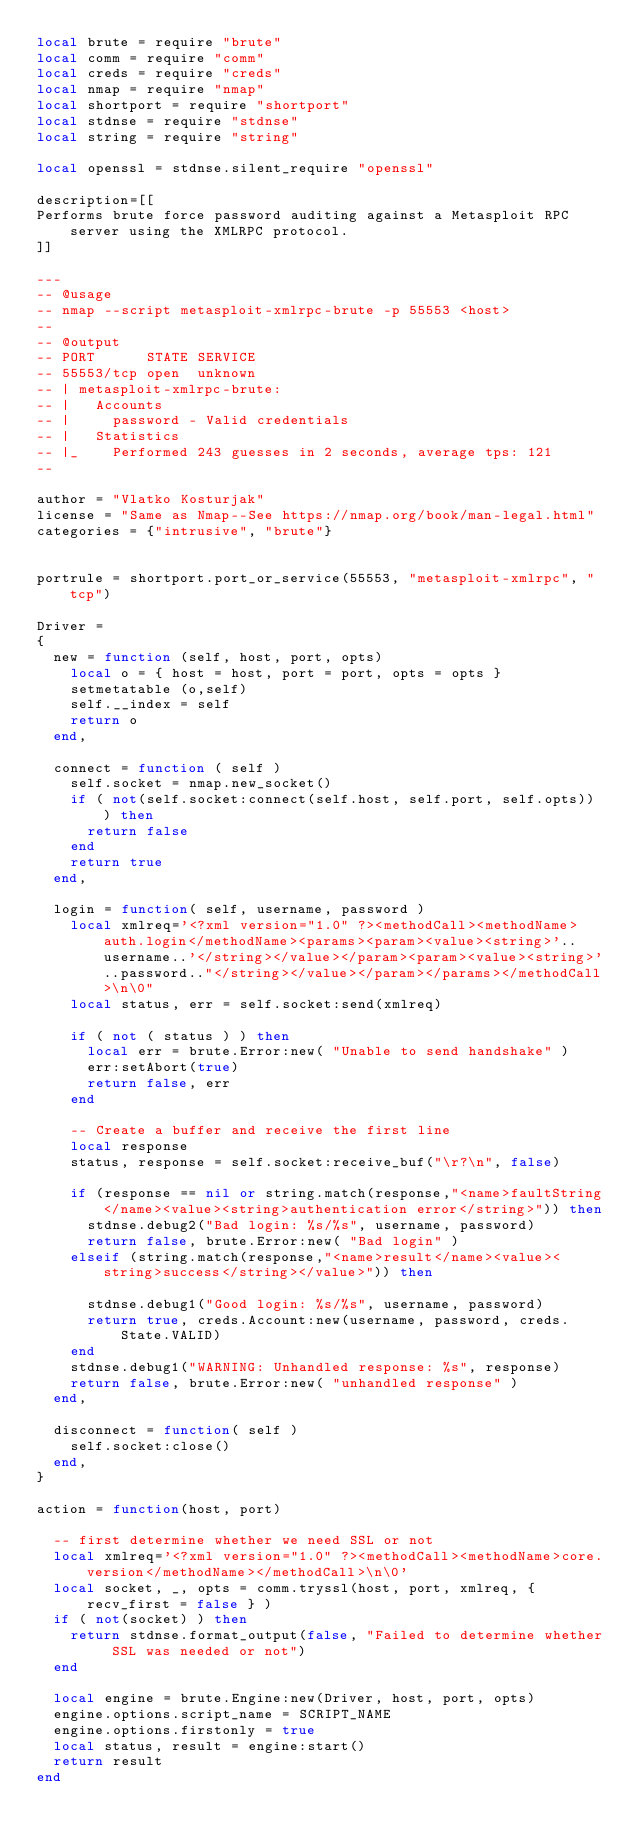Convert code to text. <code><loc_0><loc_0><loc_500><loc_500><_Lua_>local brute = require "brute"
local comm = require "comm"
local creds = require "creds"
local nmap = require "nmap"
local shortport = require "shortport"
local stdnse = require "stdnse"
local string = require "string"

local openssl = stdnse.silent_require "openssl"

description=[[
Performs brute force password auditing against a Metasploit RPC server using the XMLRPC protocol.
]]

---
-- @usage
-- nmap --script metasploit-xmlrpc-brute -p 55553 <host>
--
-- @output
-- PORT      STATE SERVICE
-- 55553/tcp open  unknown
-- | metasploit-xmlrpc-brute:
-- |   Accounts
-- |     password - Valid credentials
-- |   Statistics
-- |_    Performed 243 guesses in 2 seconds, average tps: 121
--

author = "Vlatko Kosturjak"
license = "Same as Nmap--See https://nmap.org/book/man-legal.html"
categories = {"intrusive", "brute"}


portrule = shortport.port_or_service(55553, "metasploit-xmlrpc", "tcp")

Driver =
{
  new = function (self, host, port, opts)
    local o = { host = host, port = port, opts = opts }
    setmetatable (o,self)
    self.__index = self
    return o
  end,

  connect = function ( self )
    self.socket = nmap.new_socket()
    if ( not(self.socket:connect(self.host, self.port, self.opts)) ) then
      return false
    end
    return true
  end,

  login = function( self, username, password )
    local xmlreq='<?xml version="1.0" ?><methodCall><methodName>auth.login</methodName><params><param><value><string>'..username..'</string></value></param><param><value><string>'..password.."</string></value></param></params></methodCall>\n\0"
    local status, err = self.socket:send(xmlreq)

    if ( not ( status ) ) then
      local err = brute.Error:new( "Unable to send handshake" )
      err:setAbort(true)
      return false, err
    end

    -- Create a buffer and receive the first line
    local response
    status, response = self.socket:receive_buf("\r?\n", false)

    if (response == nil or string.match(response,"<name>faultString</name><value><string>authentication error</string>")) then
      stdnse.debug2("Bad login: %s/%s", username, password)
      return false, brute.Error:new( "Bad login" )
    elseif (string.match(response,"<name>result</name><value><string>success</string></value>")) then

      stdnse.debug1("Good login: %s/%s", username, password)
      return true, creds.Account:new(username, password, creds.State.VALID)
    end
    stdnse.debug1("WARNING: Unhandled response: %s", response)
    return false, brute.Error:new( "unhandled response" )
  end,

  disconnect = function( self )
    self.socket:close()
  end,
}

action = function(host, port)

  -- first determine whether we need SSL or not
  local xmlreq='<?xml version="1.0" ?><methodCall><methodName>core.version</methodName></methodCall>\n\0'
  local socket, _, opts = comm.tryssl(host, port, xmlreq, { recv_first = false } )
  if ( not(socket) ) then
    return stdnse.format_output(false, "Failed to determine whether SSL was needed or not")
  end

  local engine = brute.Engine:new(Driver, host, port, opts)
  engine.options.script_name = SCRIPT_NAME
  engine.options.firstonly = true
  local status, result = engine:start()
  return result
end

</code> 